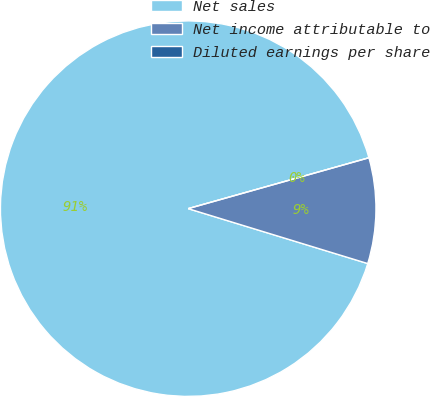Convert chart to OTSL. <chart><loc_0><loc_0><loc_500><loc_500><pie_chart><fcel>Net sales<fcel>Net income attributable to<fcel>Diluted earnings per share<nl><fcel>90.91%<fcel>9.09%<fcel>0.0%<nl></chart> 